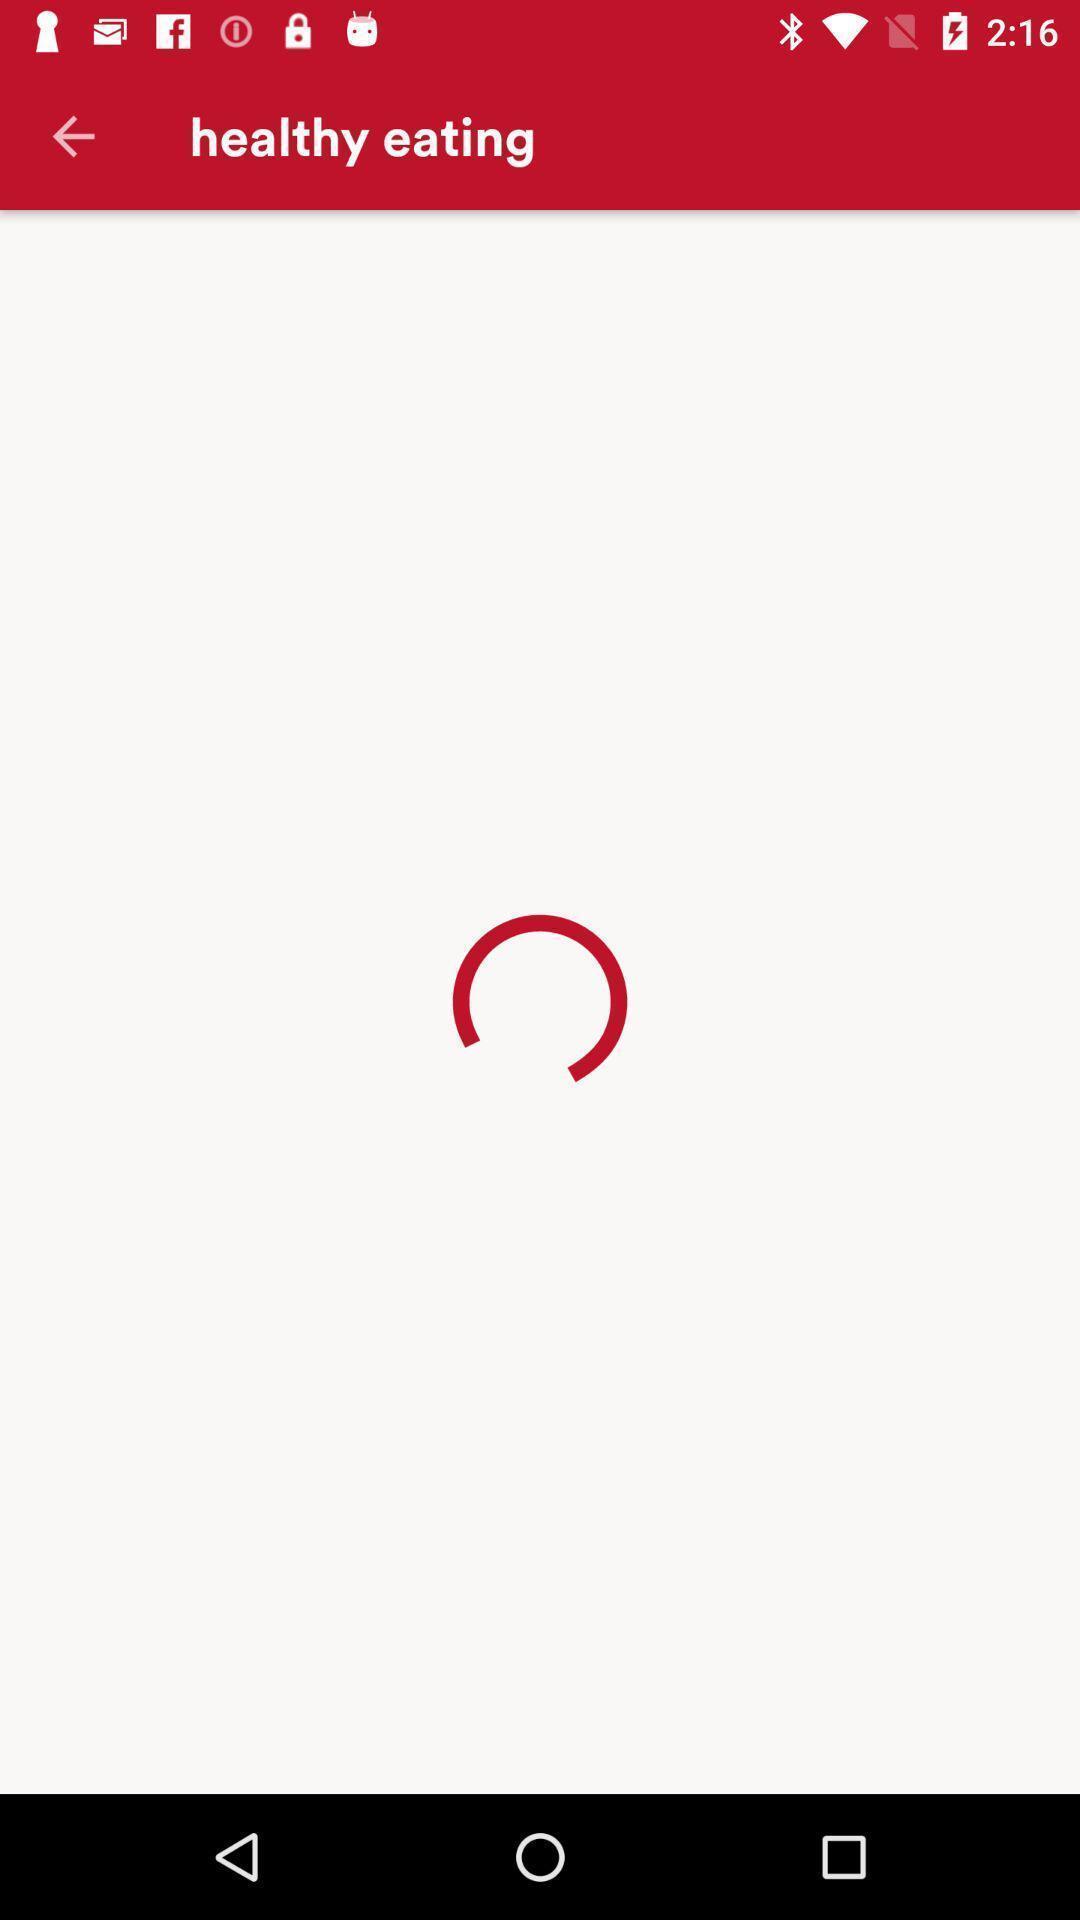Describe the key features of this screenshot. Screen shows healthy eating page. 